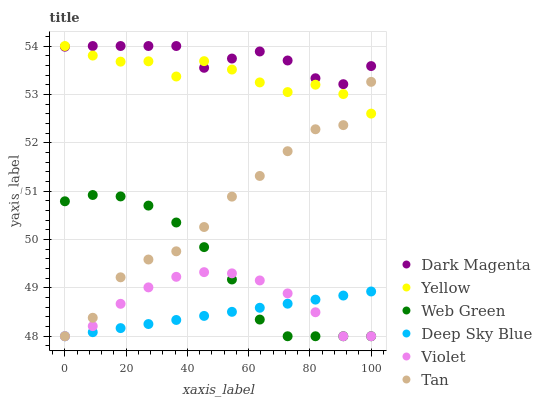Does Deep Sky Blue have the minimum area under the curve?
Answer yes or no. Yes. Does Dark Magenta have the maximum area under the curve?
Answer yes or no. Yes. Does Web Green have the minimum area under the curve?
Answer yes or no. No. Does Web Green have the maximum area under the curve?
Answer yes or no. No. Is Deep Sky Blue the smoothest?
Answer yes or no. Yes. Is Tan the roughest?
Answer yes or no. Yes. Is Web Green the smoothest?
Answer yes or no. No. Is Web Green the roughest?
Answer yes or no. No. Does Web Green have the lowest value?
Answer yes or no. Yes. Does Yellow have the lowest value?
Answer yes or no. No. Does Yellow have the highest value?
Answer yes or no. Yes. Does Web Green have the highest value?
Answer yes or no. No. Is Deep Sky Blue less than Dark Magenta?
Answer yes or no. Yes. Is Dark Magenta greater than Deep Sky Blue?
Answer yes or no. Yes. Does Dark Magenta intersect Yellow?
Answer yes or no. Yes. Is Dark Magenta less than Yellow?
Answer yes or no. No. Is Dark Magenta greater than Yellow?
Answer yes or no. No. Does Deep Sky Blue intersect Dark Magenta?
Answer yes or no. No. 